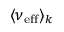<formula> <loc_0><loc_0><loc_500><loc_500>\langle \nu _ { e f f } \rangle _ { k }</formula> 